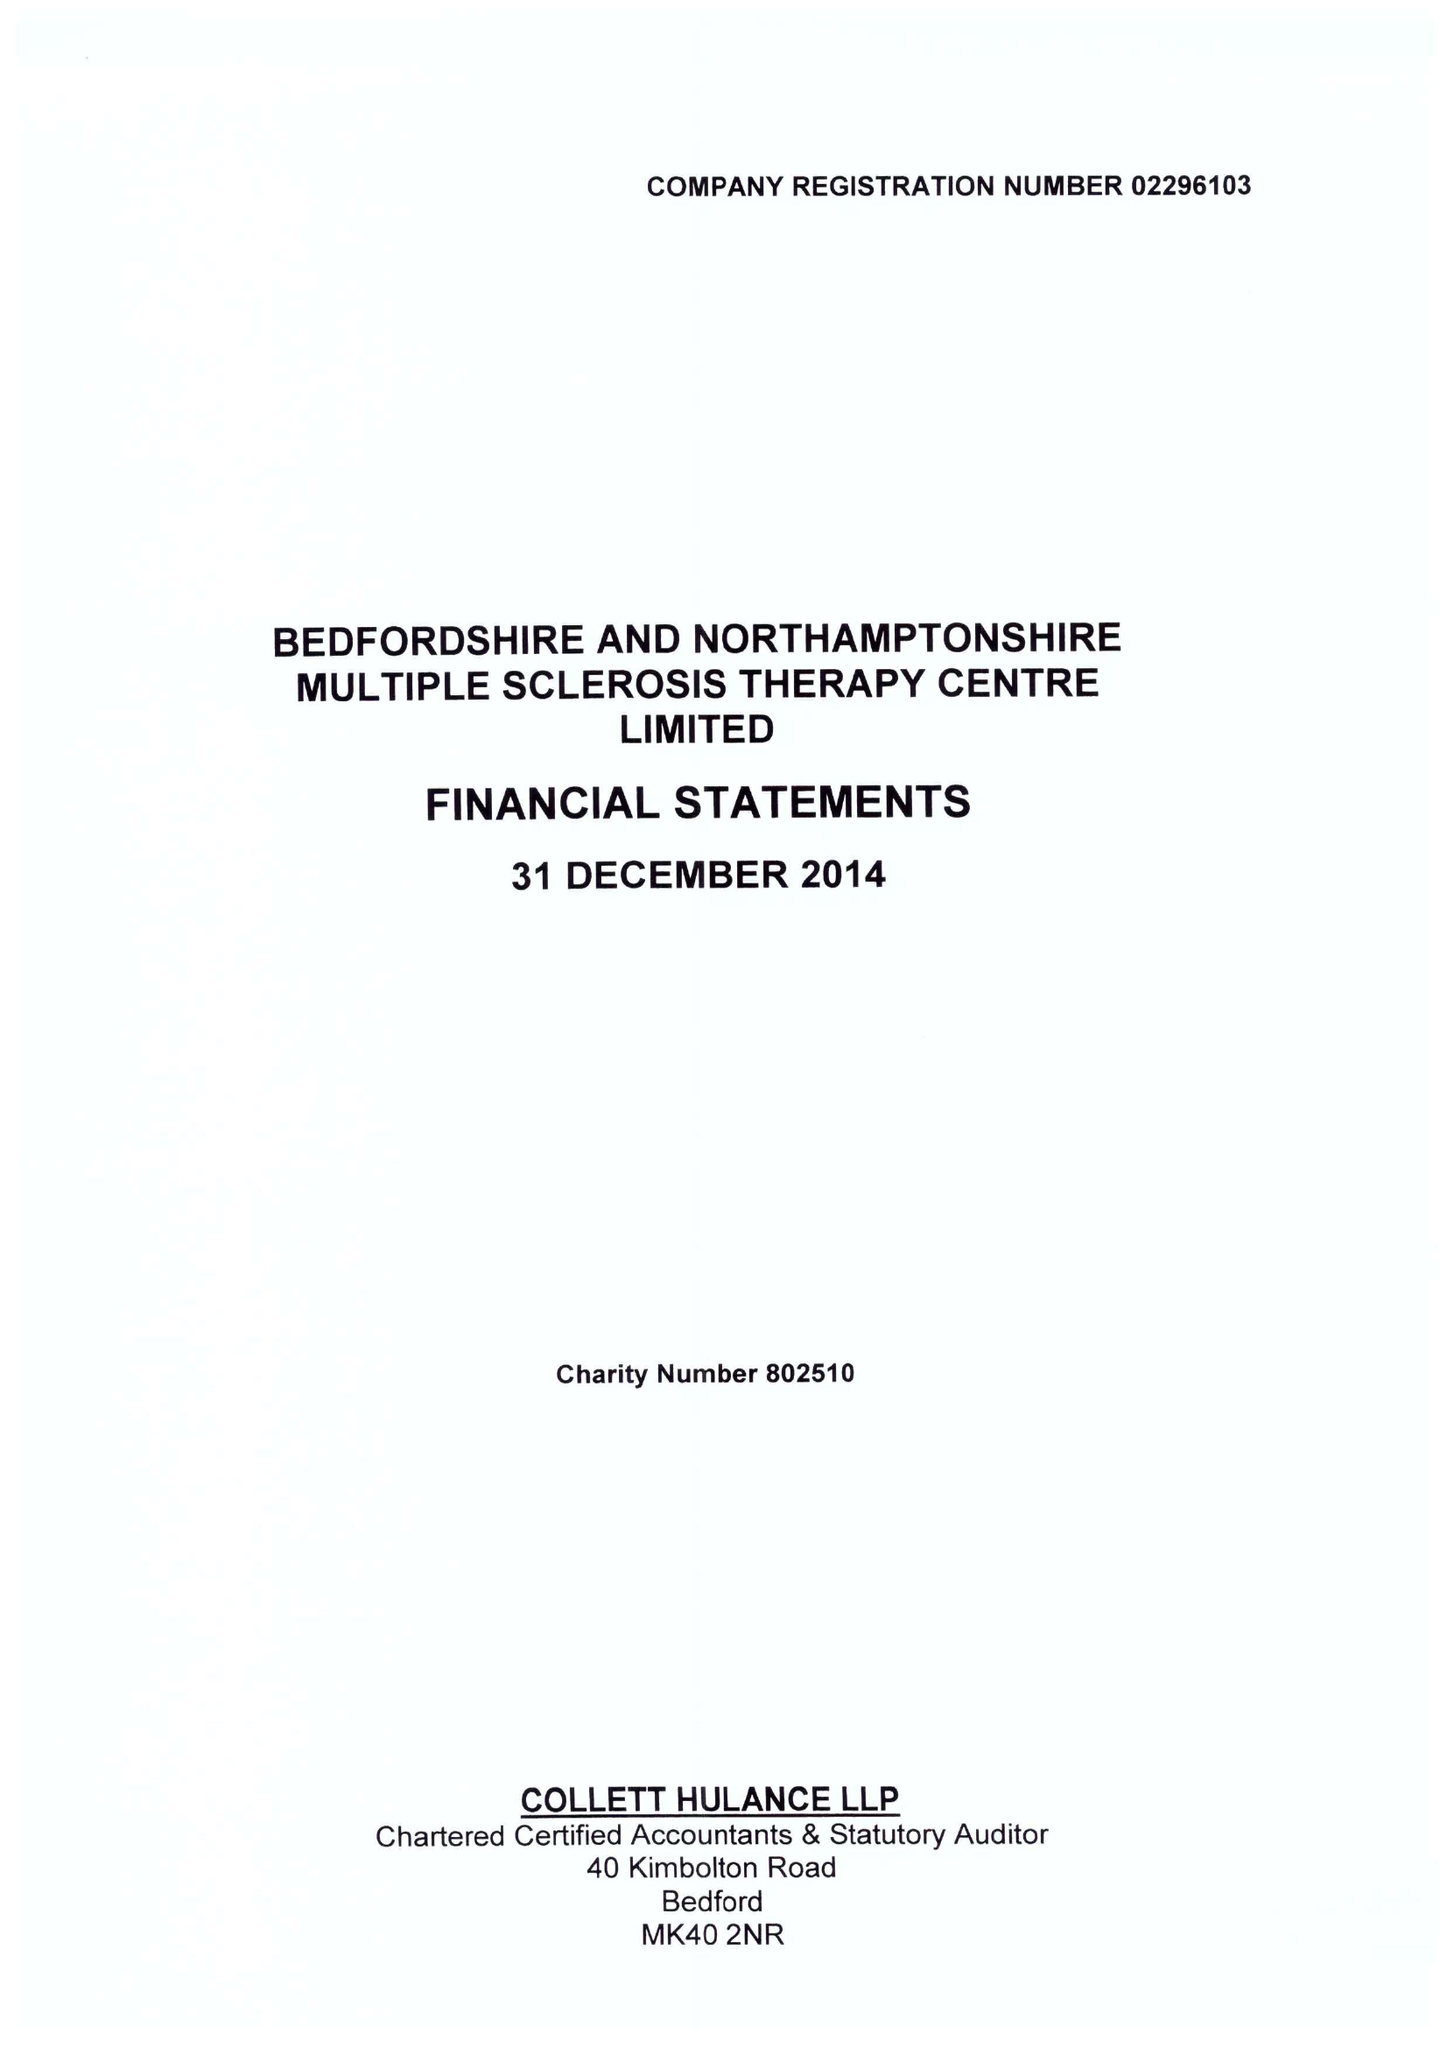What is the value for the income_annually_in_british_pounds?
Answer the question using a single word or phrase. 364556.00 